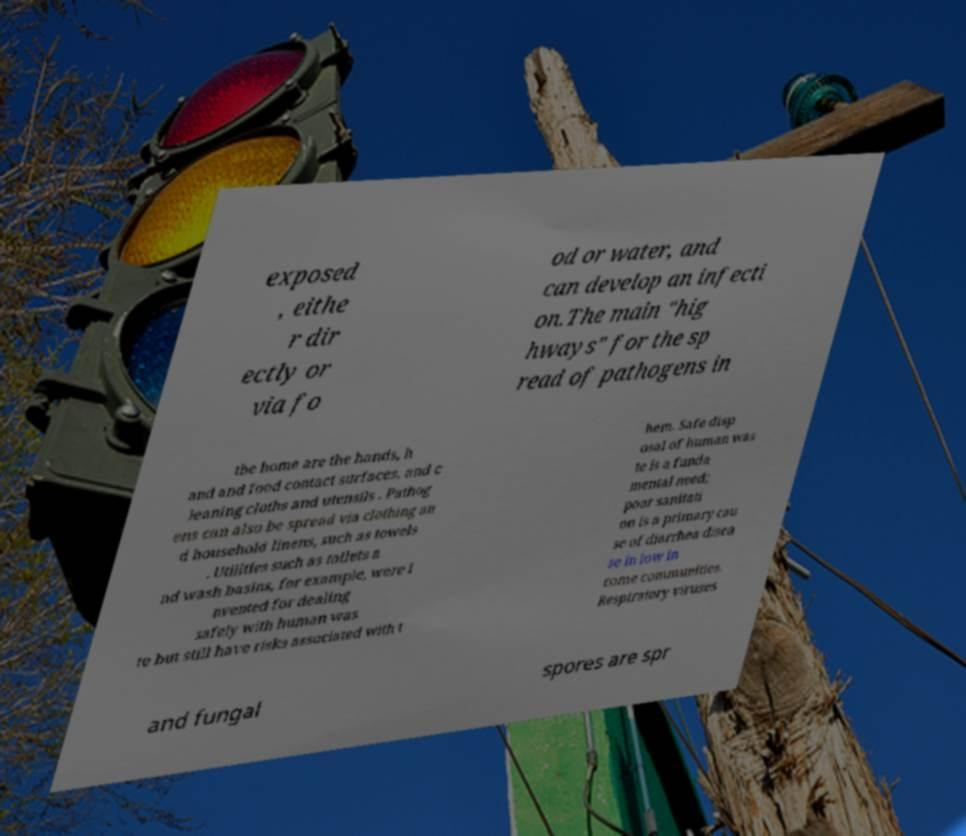Please read and relay the text visible in this image. What does it say? exposed , eithe r dir ectly or via fo od or water, and can develop an infecti on.The main "hig hways" for the sp read of pathogens in the home are the hands, h and and food contact surfaces, and c leaning cloths and utensils . Pathog ens can also be spread via clothing an d household linens, such as towels . Utilities such as toilets a nd wash basins, for example, were i nvented for dealing safely with human was te but still have risks associated with t hem. Safe disp osal of human was te is a funda mental need; poor sanitati on is a primary cau se of diarrhea disea se in low in come communities. Respiratory viruses and fungal spores are spr 